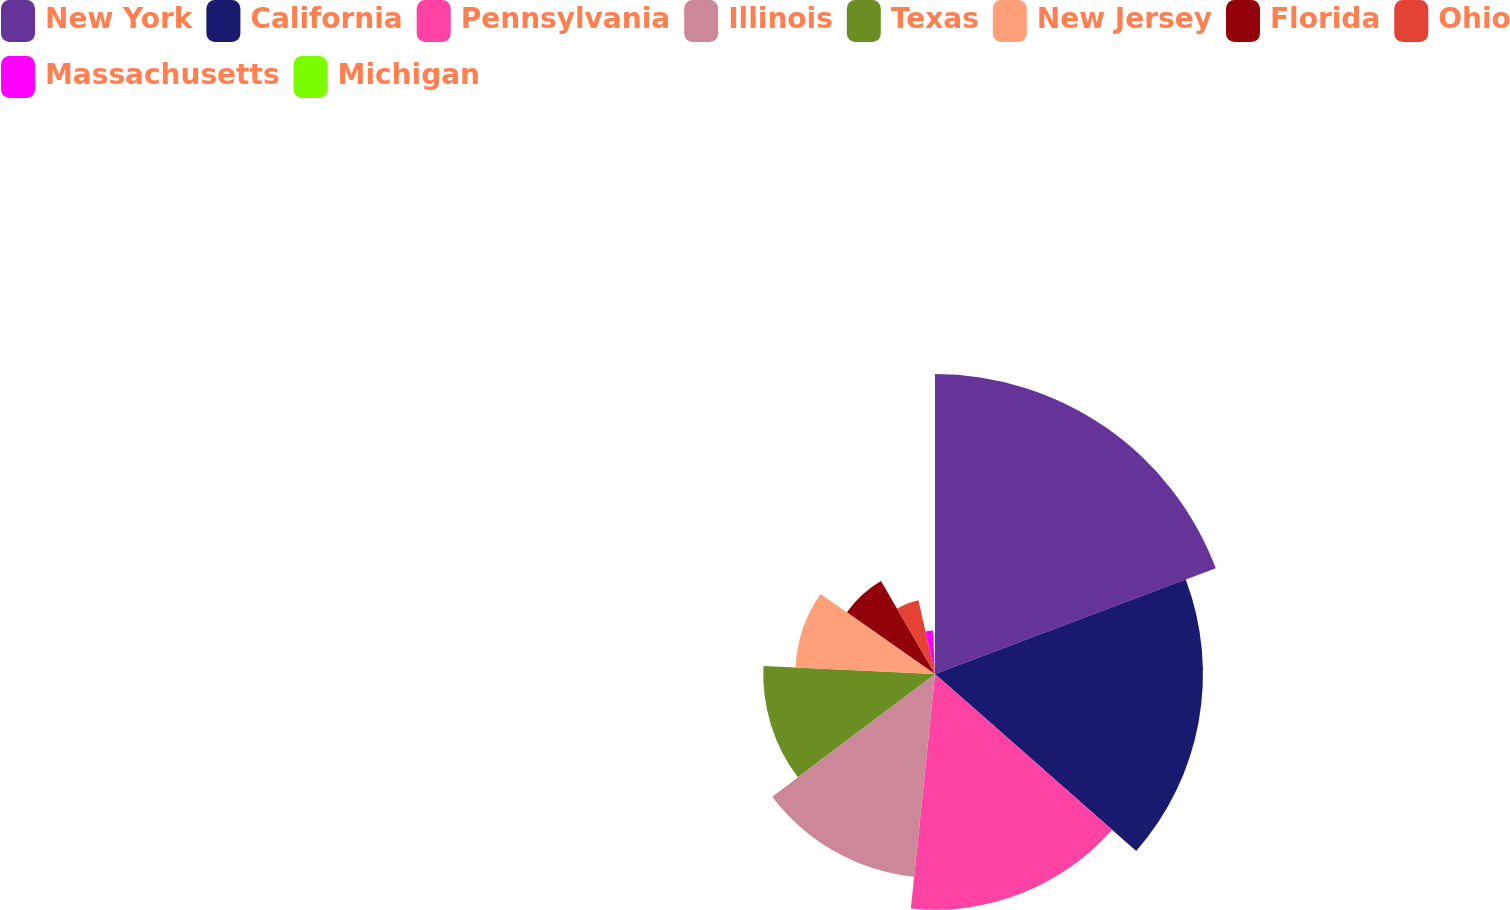<chart> <loc_0><loc_0><loc_500><loc_500><pie_chart><fcel>New York<fcel>California<fcel>Pennsylvania<fcel>Illinois<fcel>Texas<fcel>New Jersey<fcel>Florida<fcel>Ohio<fcel>Massachusetts<fcel>Michigan<nl><fcel>19.27%<fcel>17.21%<fcel>15.15%<fcel>13.09%<fcel>11.03%<fcel>8.97%<fcel>6.91%<fcel>4.85%<fcel>2.79%<fcel>0.73%<nl></chart> 